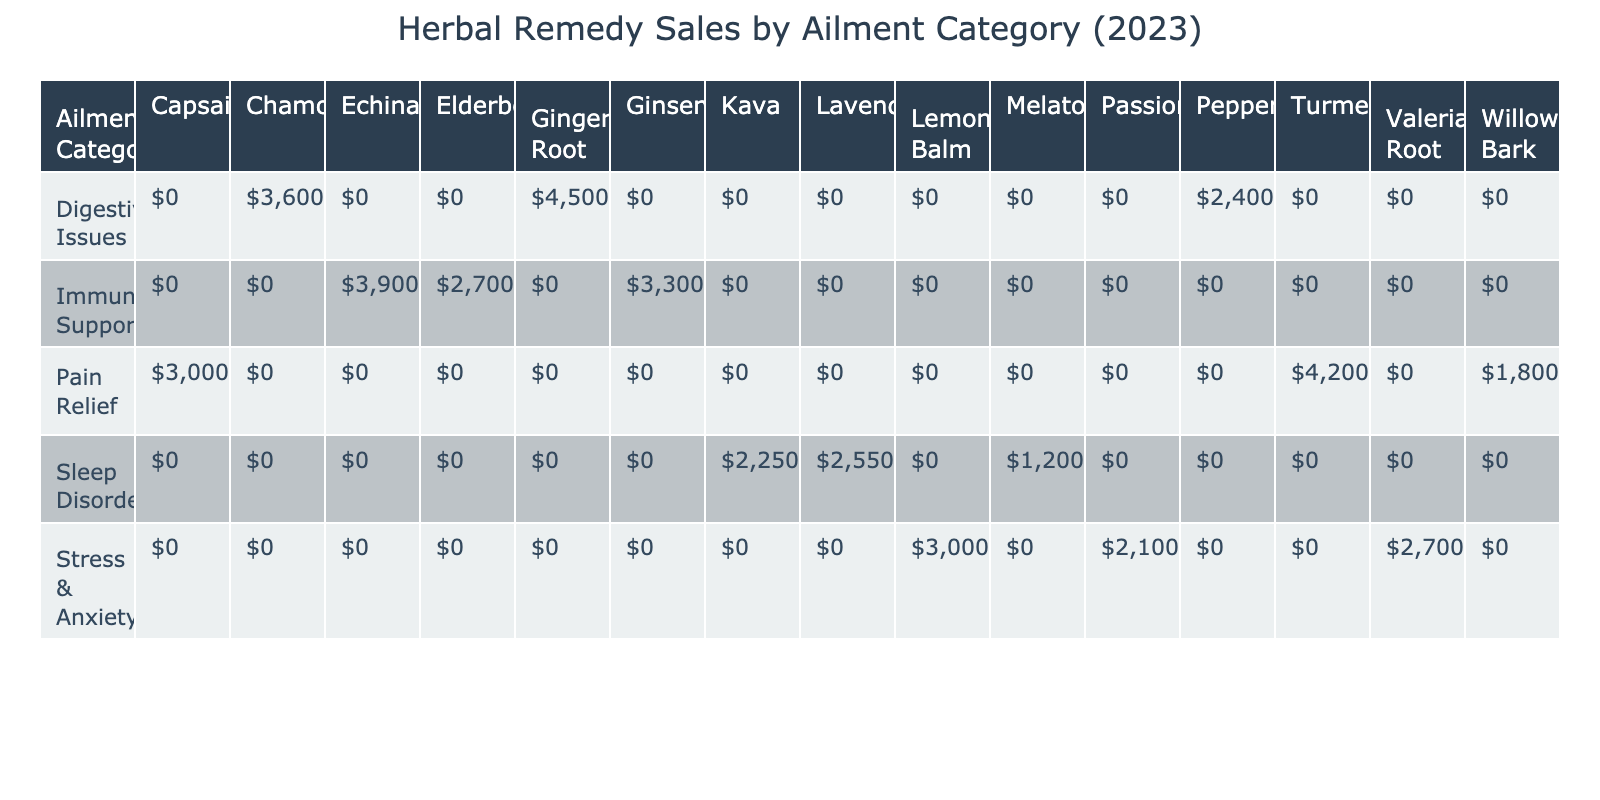What is the total sales revenue for the "Immune Support" category? The sales revenues for the three remedies in the "Immune Support" category are Echinacea ($3900), Ginseng ($3300), and Elderberry ($2700). Adding these together: 3900 + 3300 + 2700 = 9900.
Answer: $9900 Which herbal remedy sold the most units under "Pain Relief"? The sales units for the remedies under "Pain Relief" are Turmeric (1400), Capsaicin (1000), and Willow Bark (600). The one with the highest sales is Turmeric at 1400 units.
Answer: Turmeric Is the sales revenue for "Stress & Anxiety" greater than that for "Sleep Disorders"? The total sales revenues for "Stress & Anxiety" are Lemon Balm ($3000), Valerian Root ($2700), and Passionflower ($2100) totaling 3000 + 2700 + 2100 = 7800. For "Sleep Disorders," total sales are Lavender ($2550), Kava ($2250), and Melatonin ($1200) totaling 2550 + 2250 + 1200 = 6000. Since 7800 > 6000, the answer is yes.
Answer: Yes What is the average sales revenue per unit for the remedies under "Digestive Issues"? The sales revenues for the remedies under "Digestive Issues" are Ginger Root ($4500), Chamomile ($3600), and Peppermint ($2400). To find the average, first calculate the sum: 4500 + 3600 + 2400 = 10500. Then divide by the number of remedies (3): 10500 / 3 = 3500.
Answer: $3500 Which category has the least total units sold? For each category, the units sold are as follows: Digestive Issues (1500 + 1200 + 800 = 3500), Stress & Anxiety (1000 + 900 + 700 = 2600), Immune Support (1300 + 1100 + 900 = 3300), Pain Relief (1400 + 1000 + 600 = 3000), and Sleep Disorders (850 + 750 + 400 = 2000). The category with the least is "Sleep Disorders" with 2000 units.
Answer: Sleep Disorders What is the difference in sales revenue between "Pain Relief" and "Immune Support"? The total sales revenue for "Pain Relief" is Turmeric ($4200), Capsaicin ($3000), and Willow Bark ($1800). That totals to 4200 + 3000 + 1800 = 9000. "Immune Support" has a total revenue of 3900 + 3300 + 2700 = 9900. The difference is 9900 - 9000 = 900.
Answer: $900 Is there a remedy that sold more than 1000 units under "Digestive Issues"? The remedies sold under "Digestive Issues" are Ginger Root (1500), Chamomile (1200), and Peppermint (800). Both Ginger Root and Chamomile sold more than 1000 units, confirming yes.
Answer: Yes Which ailment category has the highest total unit sales, and what is that number? The total units sold by category are: Digestive Issues (3500), Stress & Anxiety (2600), Immune Support (3300), Pain Relief (3000), and Sleep Disorders (2000). The highest is "Digestive Issues" with 3500 units.
Answer: Digestive Issues with 3500 units 